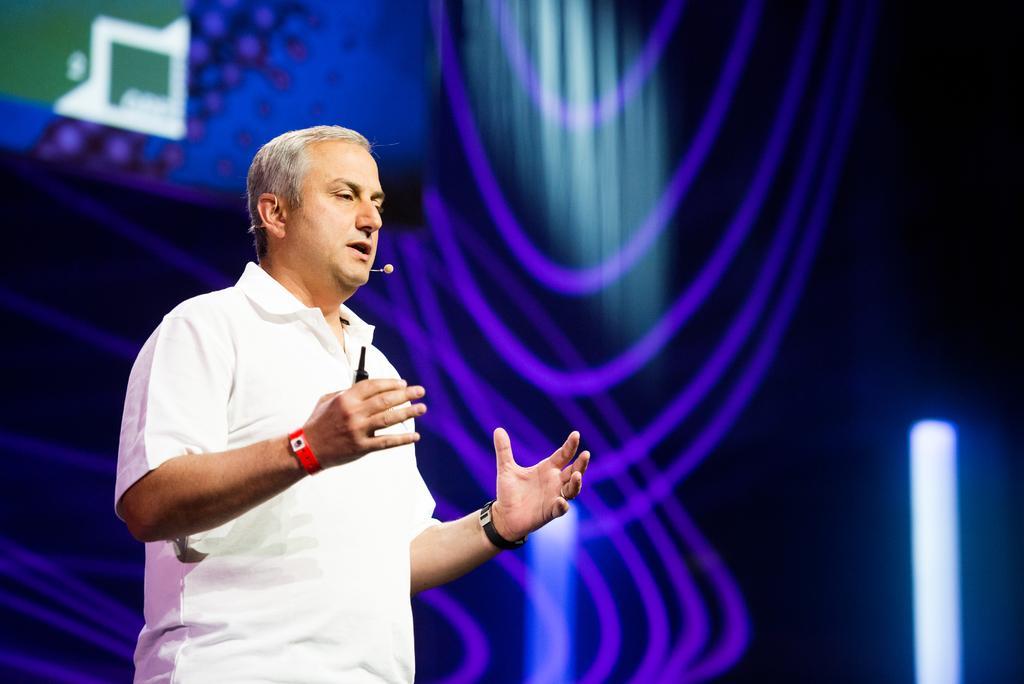Describe this image in one or two sentences. In this image I can see the person wearing the white color dress and holding the black color object. At the back of the person I can see the screen. And there is a blue and black background. 